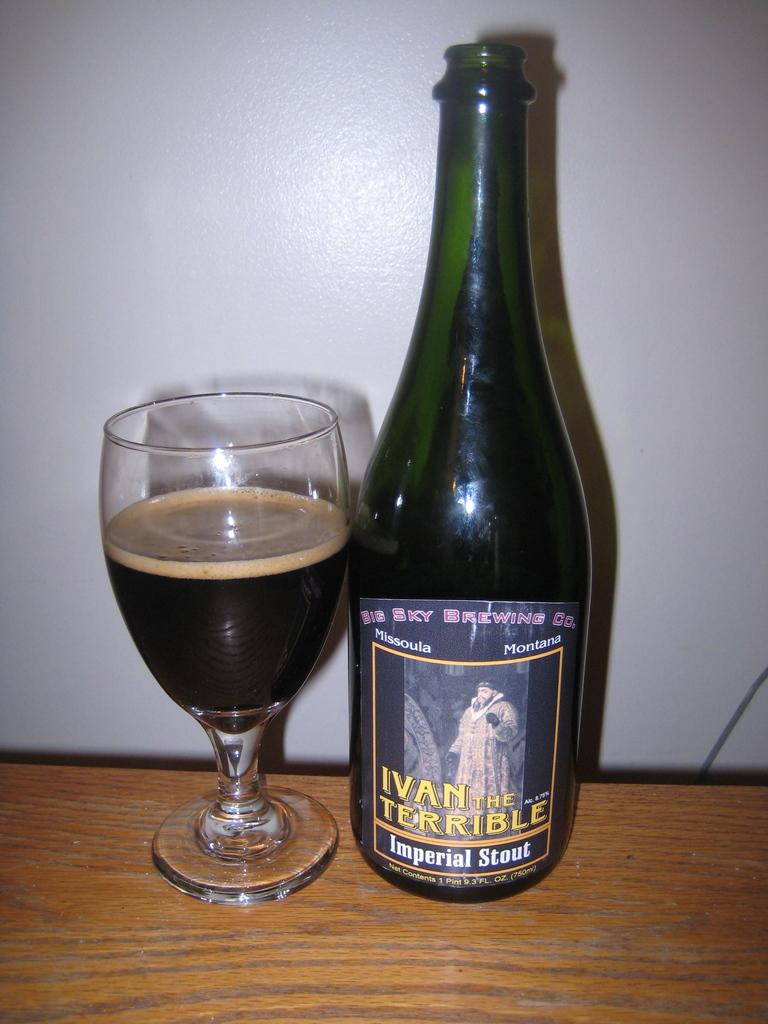<image>
Describe the image concisely. An Imperial Stout is poured into a glass on the table. 